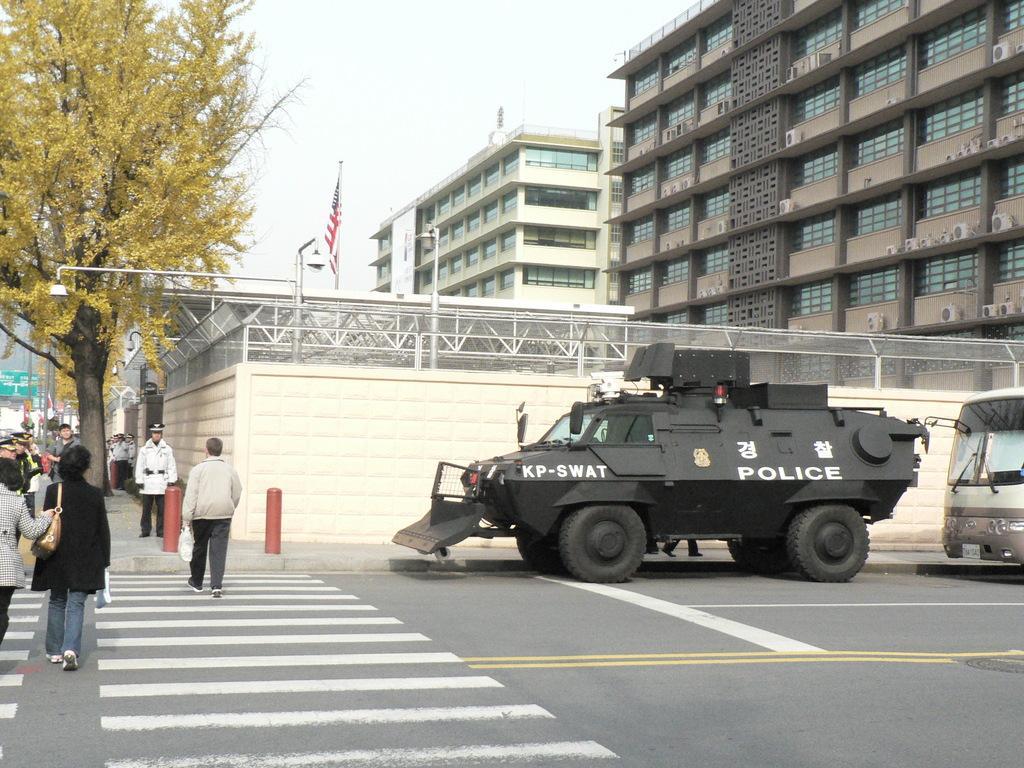Describe this image in one or two sentences. In this image on the right side, I can see the vehicles with some text written on it. I can see some people on the road. On the left side I can see a tree. I can see a flag. In the background, I can see the buildings and the sky. 